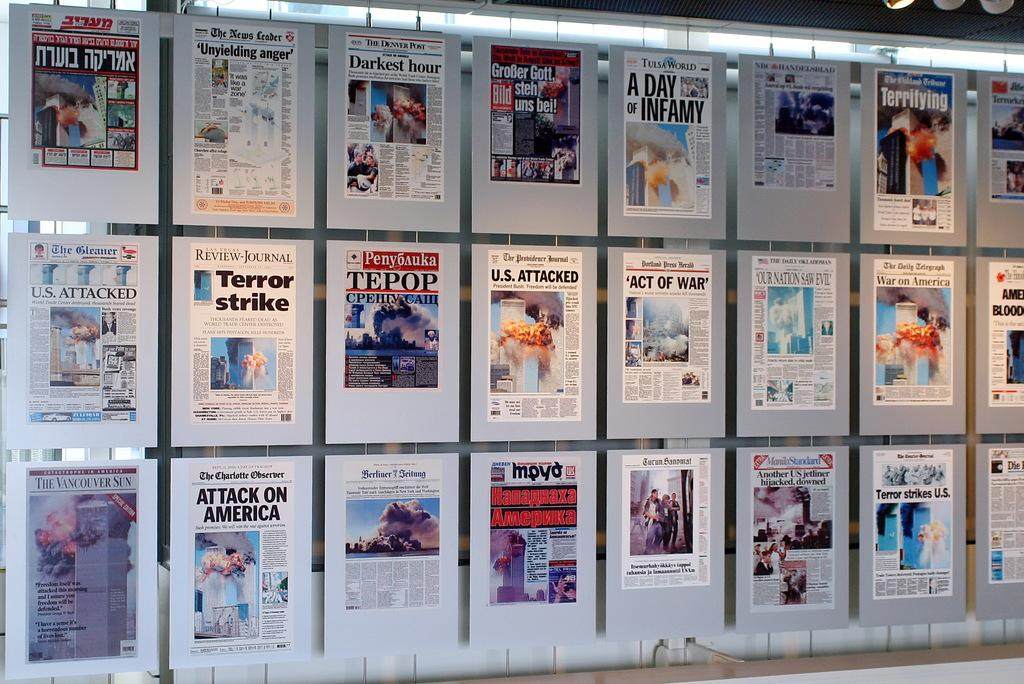<image>
Share a concise interpretation of the image provided. Many framed newspaper covers including the Detroit Post that all have 9/11 as their headline. 